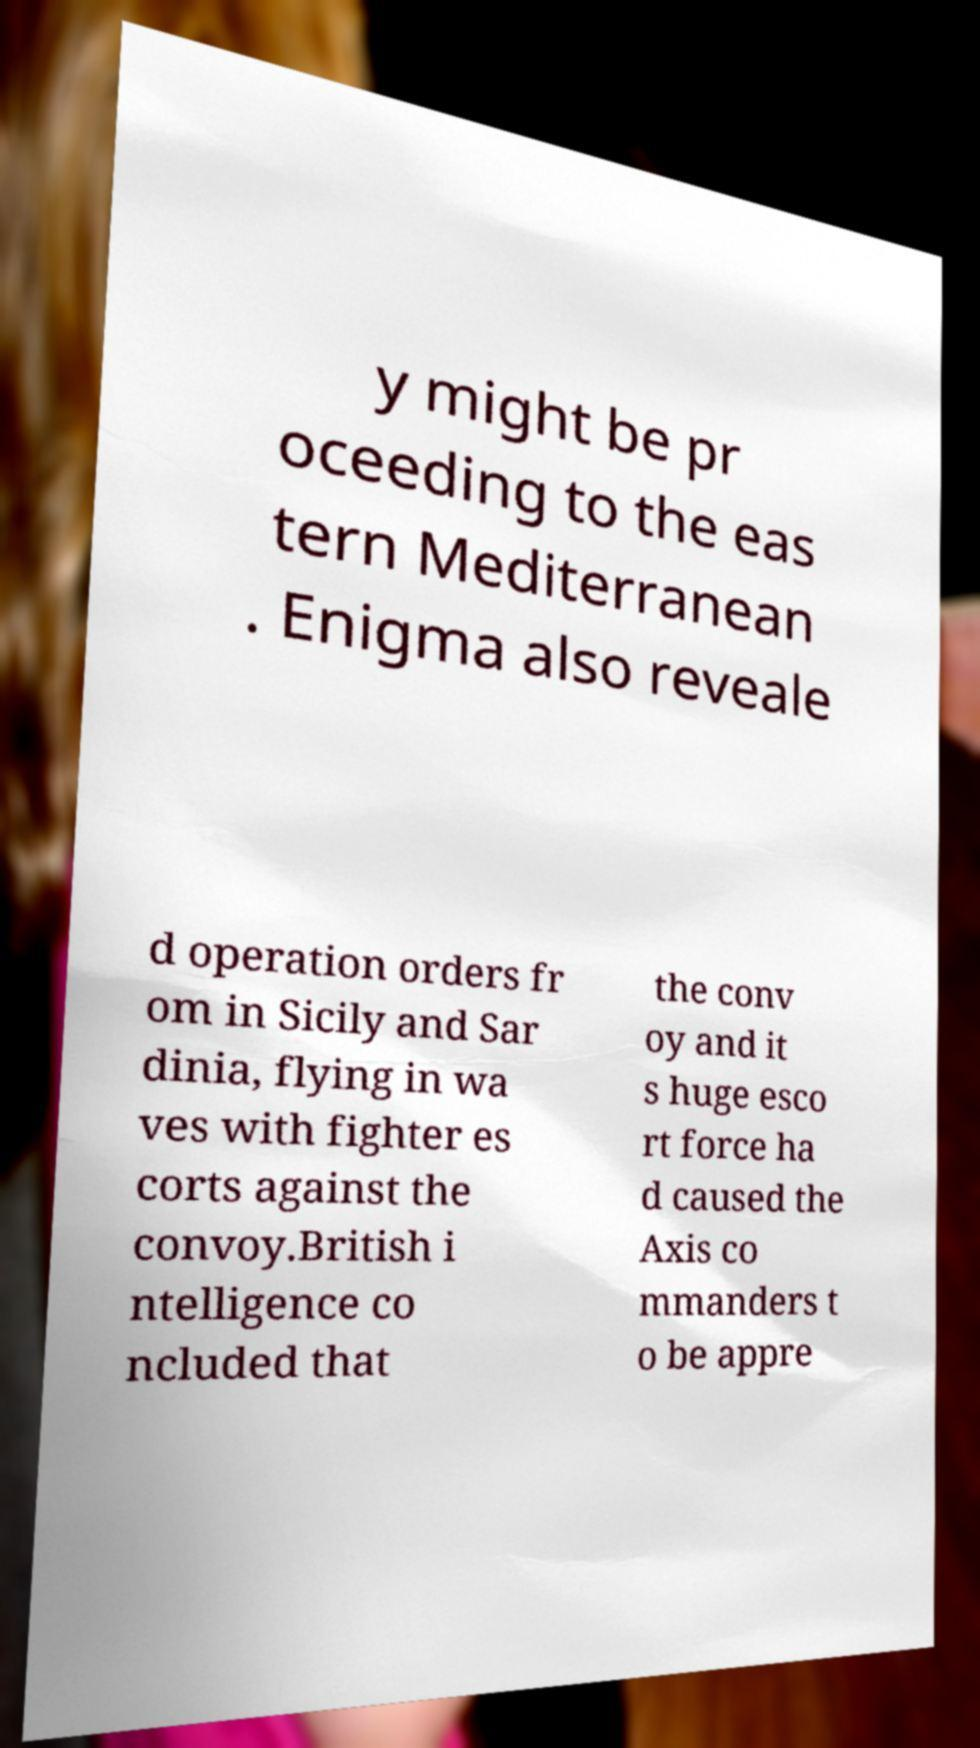There's text embedded in this image that I need extracted. Can you transcribe it verbatim? y might be pr oceeding to the eas tern Mediterranean . Enigma also reveale d operation orders fr om in Sicily and Sar dinia, flying in wa ves with fighter es corts against the convoy.British i ntelligence co ncluded that the conv oy and it s huge esco rt force ha d caused the Axis co mmanders t o be appre 